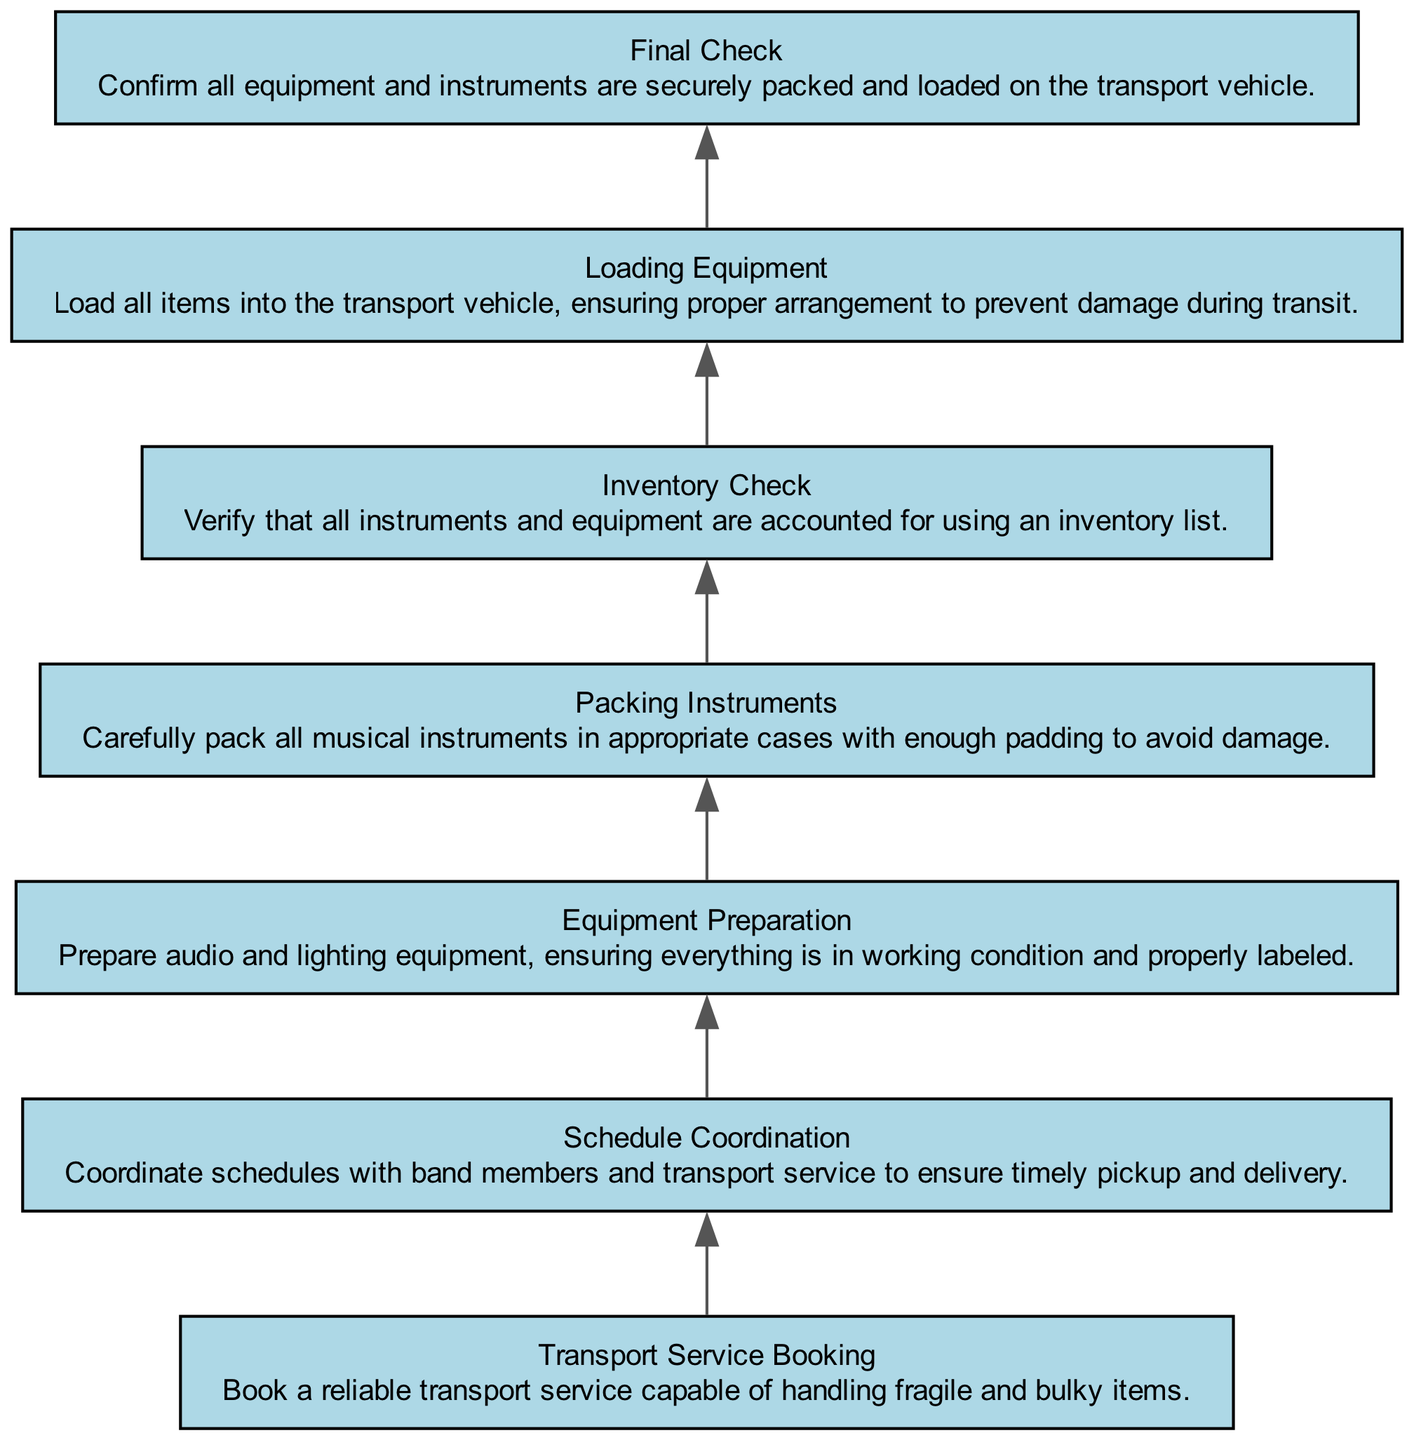What is the last step in the flow? The last step listed in the flow chart is "Final Check," which indicates a confirmation of equipment being secure.
Answer: Final Check How many steps are in the flow? By counting each element listed in the diagram, there are a total of 7 steps from Transport Service Booking to Final Check.
Answer: 7 What is the first step in the process? The first step in the flow is "Transport Service Booking," which involves arranging for reliable transport services.
Answer: Transport Service Booking What does "Loading Equipment" involve? "Loading Equipment" consists of placing all items into the transport vehicle with care to prevent damage.
Answer: Load all items Which step involves verifying items? The step that involves verifying items is "Inventory Check," ensuring all instruments and equipment are accounted for.
Answer: Inventory Check How does "Schedule Coordination" relate to "Transport Service Booking"? "Schedule Coordination" ensures that the timings align with the bookings made in "Transport Service Booking," contributing to the efficiency of the transportation process.
Answer: Timely coordination What is required before "Final Check"? Before reaching the "Final Check," all prior steps including loading and verifying must be completed to ensure readiness for transport.
Answer: All prior steps Which step comes immediately before "Loading Equipment"? The step that comes immediately before "Loading Equipment" is "Packing Instruments," ensuring instruments are protected before loading.
Answer: Packing Instruments 